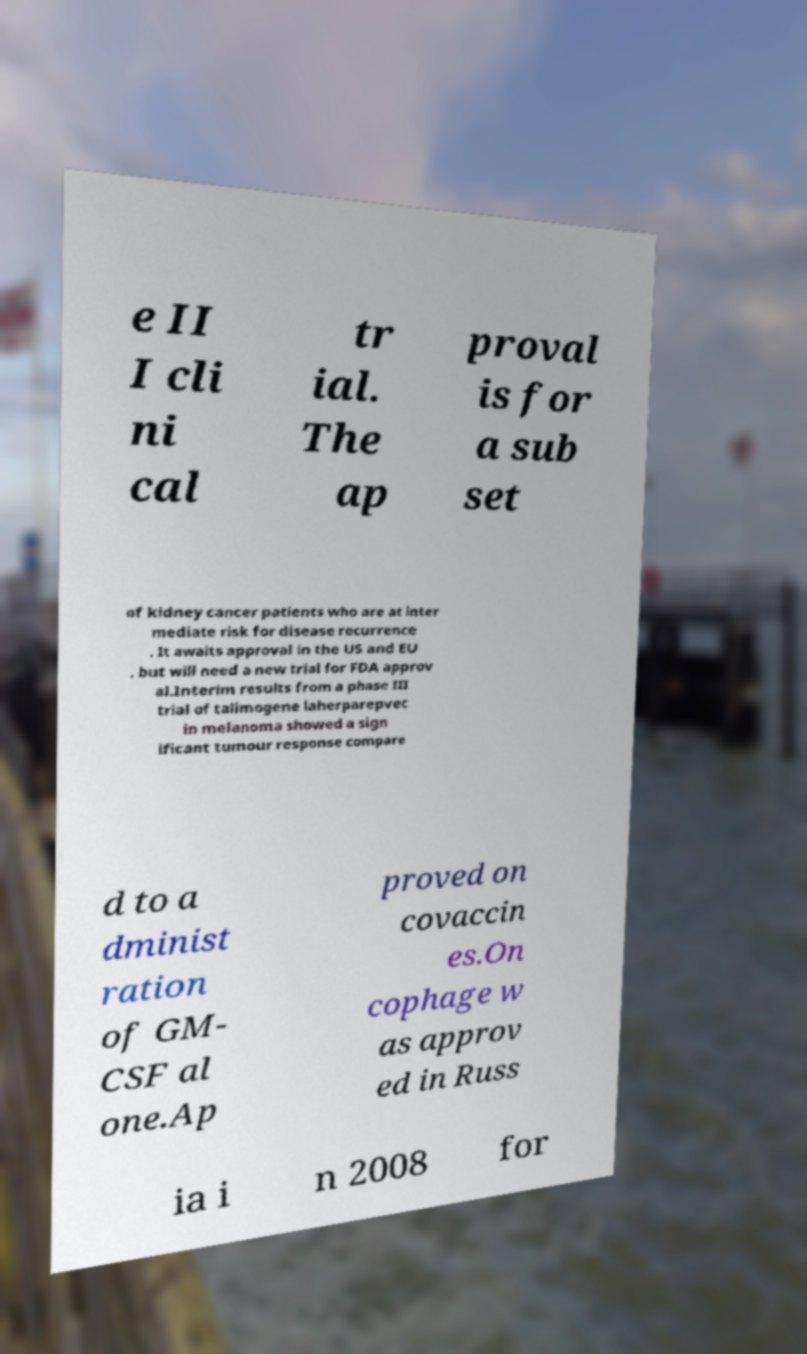There's text embedded in this image that I need extracted. Can you transcribe it verbatim? e II I cli ni cal tr ial. The ap proval is for a sub set of kidney cancer patients who are at inter mediate risk for disease recurrence . It awaits approval in the US and EU . but will need a new trial for FDA approv al.Interim results from a phase III trial of talimogene laherparepvec in melanoma showed a sign ificant tumour response compare d to a dminist ration of GM- CSF al one.Ap proved on covaccin es.On cophage w as approv ed in Russ ia i n 2008 for 